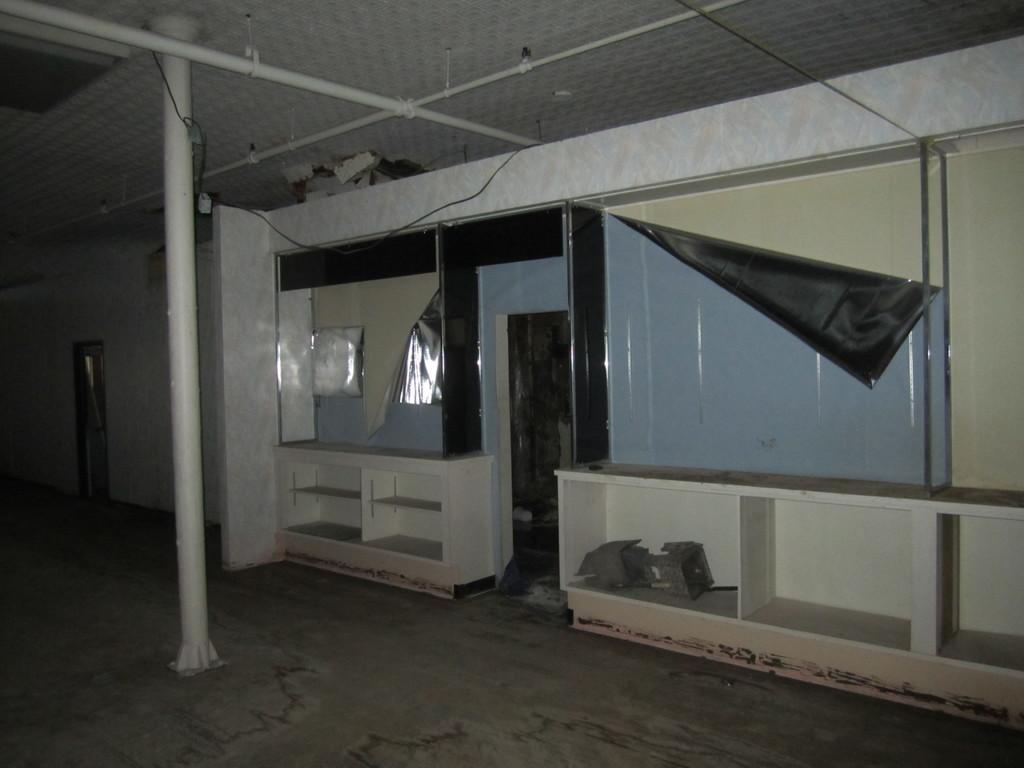Describe this image in one or two sentences. This is an inside view of a room, where there are shelves, iron rods and some other items. 